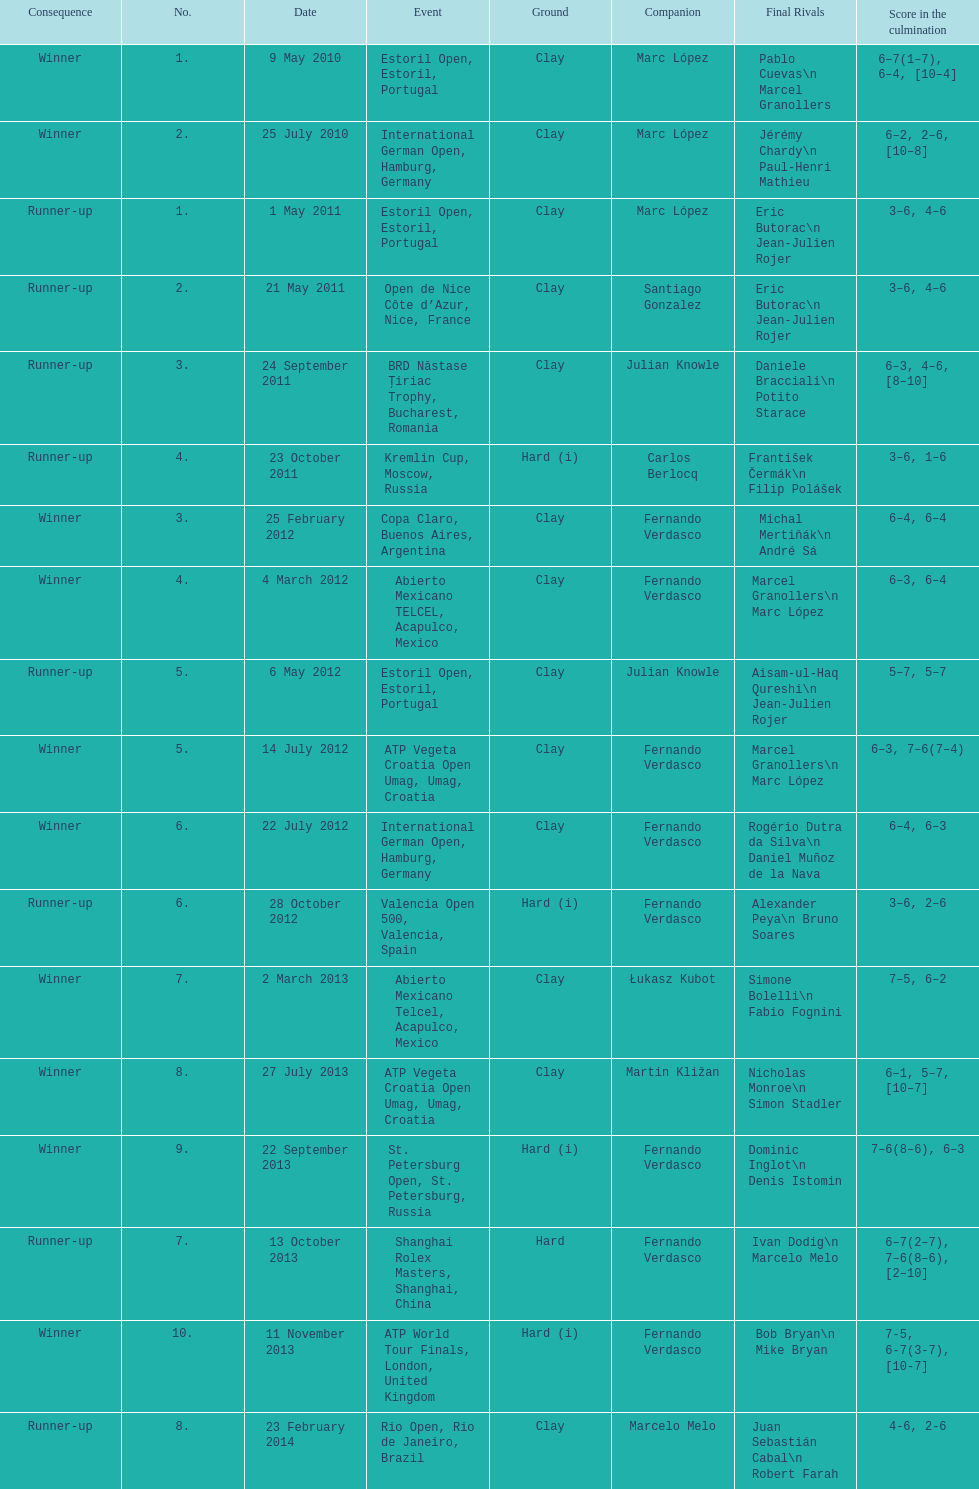What is the number of winning outcomes? 10. 